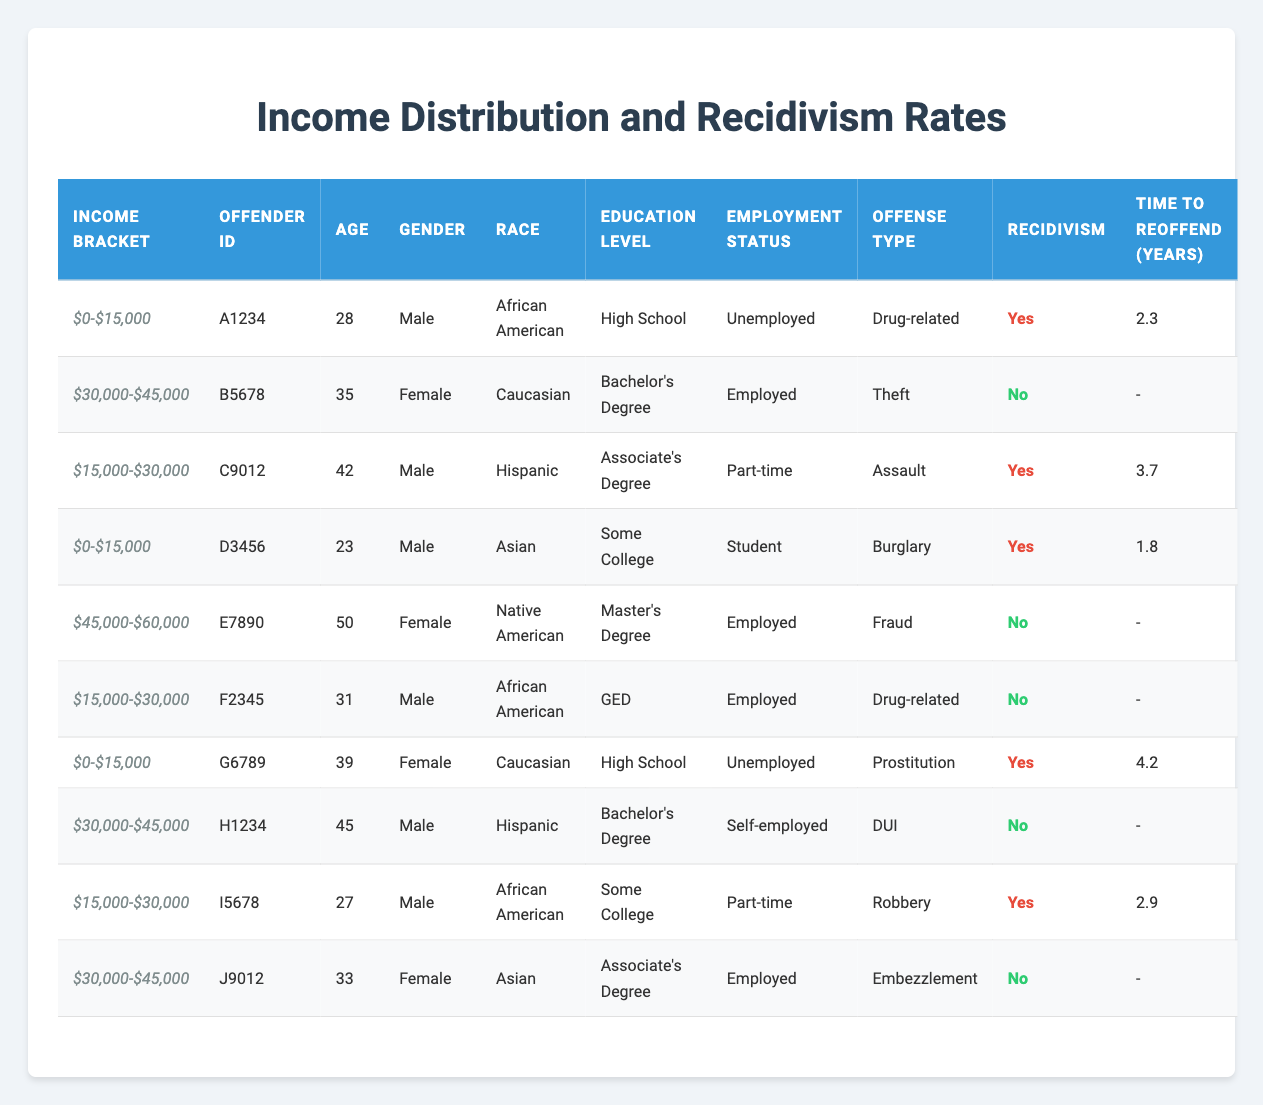What is the most common income bracket among offenders in the table? There are three distinct income brackets: $0-$15,000, $15,000-$30,000, and $30,000-$45,000. By counting the occurrences in the table, the $0-$15,000 bracket appears 4 times, $15,000-$30,000 appears 3 times, and $30,000-$45,000 appears 3 times. Therefore, the most common income bracket is $0-$15,000.
Answer: $0-$15,000 How many offenders have reoffended within the first two years? Inspecting the table, the offenders who recidivated and have a time to reoffend of less than or equal to 2 years are A1234 (2.3 years), D3456 (1.8 years), and I5678 (2.9 years). Counting these, we find 2 offenders fit this criterion.
Answer: 2 Is there any offender with a master's degree who reoffended? Reviewing the table, E7890 is the only offender listed with a master's degree, and her recidivism status is "No." Thus, there are no offenders with a master's degree who have reoffended.
Answer: No What is the average time to reoffend for all offenders who have recidivated? The offenders who reoffended are A1234 (2.3 years), C9012 (3.7 years), D3456 (1.8 years), G6789 (4.2 years), and I5678 (2.9 years). To find the average, we first sum these times: 2.3 + 3.7 + 1.8 + 4.2 + 2.9 = 15.9 years. Since there are 5 offenders, we divide the total time by 5: 15.9 / 5 = 3.18 years.
Answer: 3.18 How many females in the table have a recorded offense of "Theft"? Looking at the entries, there is one female offender with an offense of "Theft," which is B5678. Thus, the total count is one female offender for this offense.
Answer: 1 